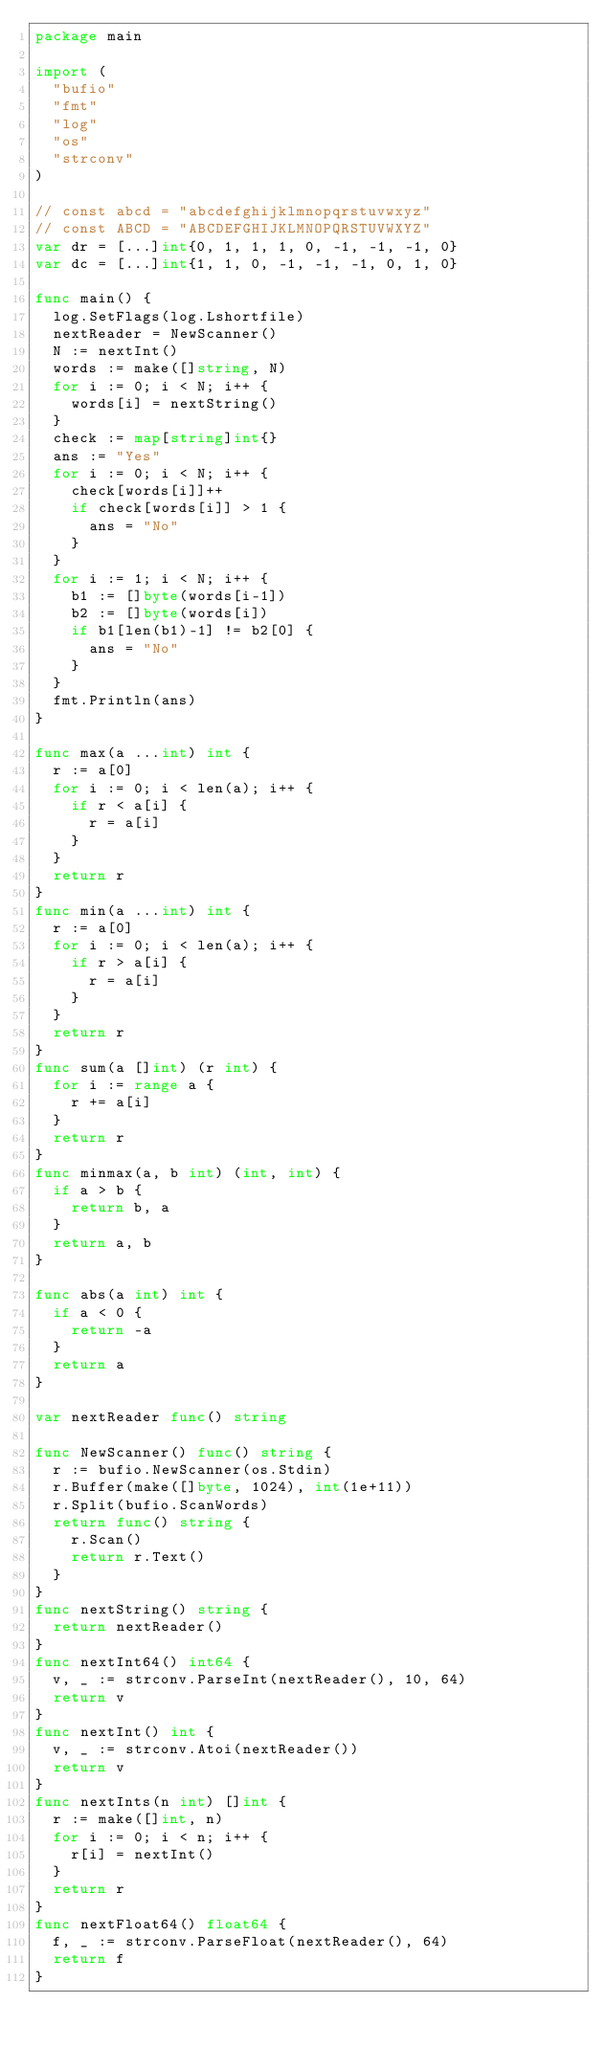Convert code to text. <code><loc_0><loc_0><loc_500><loc_500><_Go_>package main

import (
	"bufio"
	"fmt"
	"log"
	"os"
	"strconv"
)

// const abcd = "abcdefghijklmnopqrstuvwxyz"
// const ABCD = "ABCDEFGHIJKLMNOPQRSTUVWXYZ"
var dr = [...]int{0, 1, 1, 1, 0, -1, -1, -1, 0}
var dc = [...]int{1, 1, 0, -1, -1, -1, 0, 1, 0}

func main() {
	log.SetFlags(log.Lshortfile)
	nextReader = NewScanner()
	N := nextInt()
	words := make([]string, N)
	for i := 0; i < N; i++ {
		words[i] = nextString()
	}
	check := map[string]int{}
	ans := "Yes"
	for i := 0; i < N; i++ {
		check[words[i]]++
		if check[words[i]] > 1 {
			ans = "No"
		}
	}
	for i := 1; i < N; i++ {
		b1 := []byte(words[i-1])
		b2 := []byte(words[i])
		if b1[len(b1)-1] != b2[0] {
			ans = "No"
		}
	}
	fmt.Println(ans)
}

func max(a ...int) int {
	r := a[0]
	for i := 0; i < len(a); i++ {
		if r < a[i] {
			r = a[i]
		}
	}
	return r
}
func min(a ...int) int {
	r := a[0]
	for i := 0; i < len(a); i++ {
		if r > a[i] {
			r = a[i]
		}
	}
	return r
}
func sum(a []int) (r int) {
	for i := range a {
		r += a[i]
	}
	return r
}
func minmax(a, b int) (int, int) {
	if a > b {
		return b, a
	}
	return a, b
}

func abs(a int) int {
	if a < 0 {
		return -a
	}
	return a
}

var nextReader func() string

func NewScanner() func() string {
	r := bufio.NewScanner(os.Stdin)
	r.Buffer(make([]byte, 1024), int(1e+11))
	r.Split(bufio.ScanWords)
	return func() string {
		r.Scan()
		return r.Text()
	}
}
func nextString() string {
	return nextReader()
}
func nextInt64() int64 {
	v, _ := strconv.ParseInt(nextReader(), 10, 64)
	return v
}
func nextInt() int {
	v, _ := strconv.Atoi(nextReader())
	return v
}
func nextInts(n int) []int {
	r := make([]int, n)
	for i := 0; i < n; i++ {
		r[i] = nextInt()
	}
	return r
}
func nextFloat64() float64 {
	f, _ := strconv.ParseFloat(nextReader(), 64)
	return f
}
</code> 